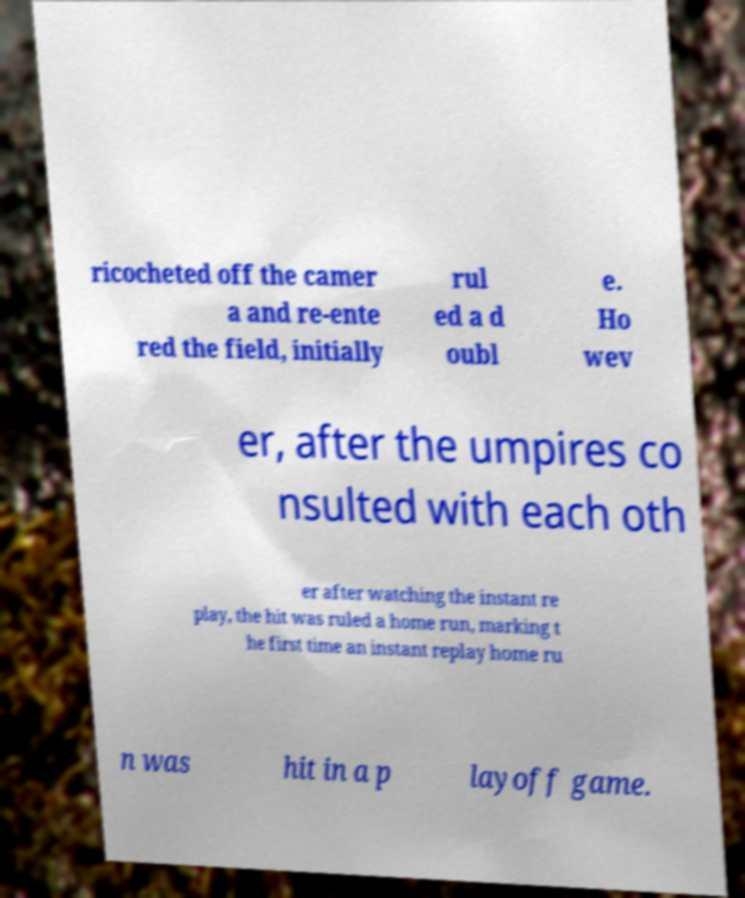Could you assist in decoding the text presented in this image and type it out clearly? ricocheted off the camer a and re-ente red the field, initially rul ed a d oubl e. Ho wev er, after the umpires co nsulted with each oth er after watching the instant re play, the hit was ruled a home run, marking t he first time an instant replay home ru n was hit in a p layoff game. 